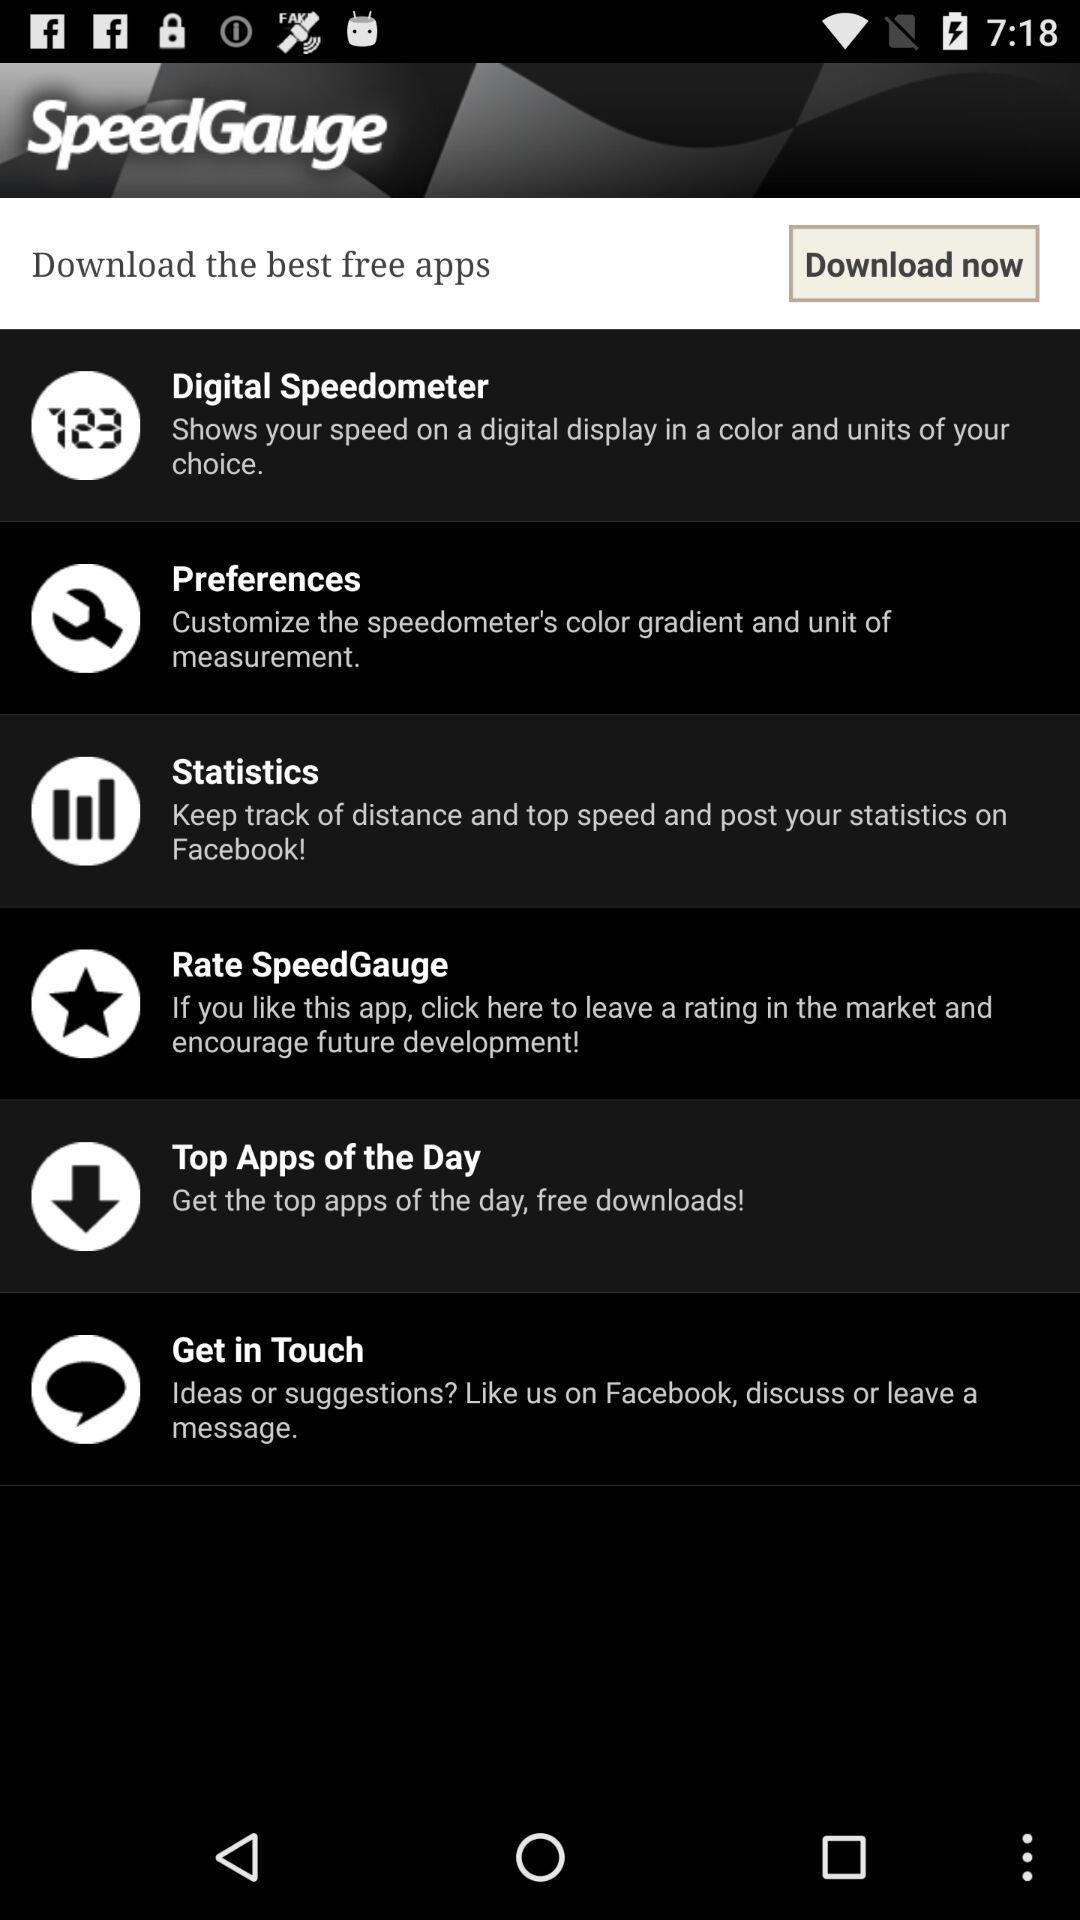What is the name of the application? The name of the application is "SpeedGauge". 